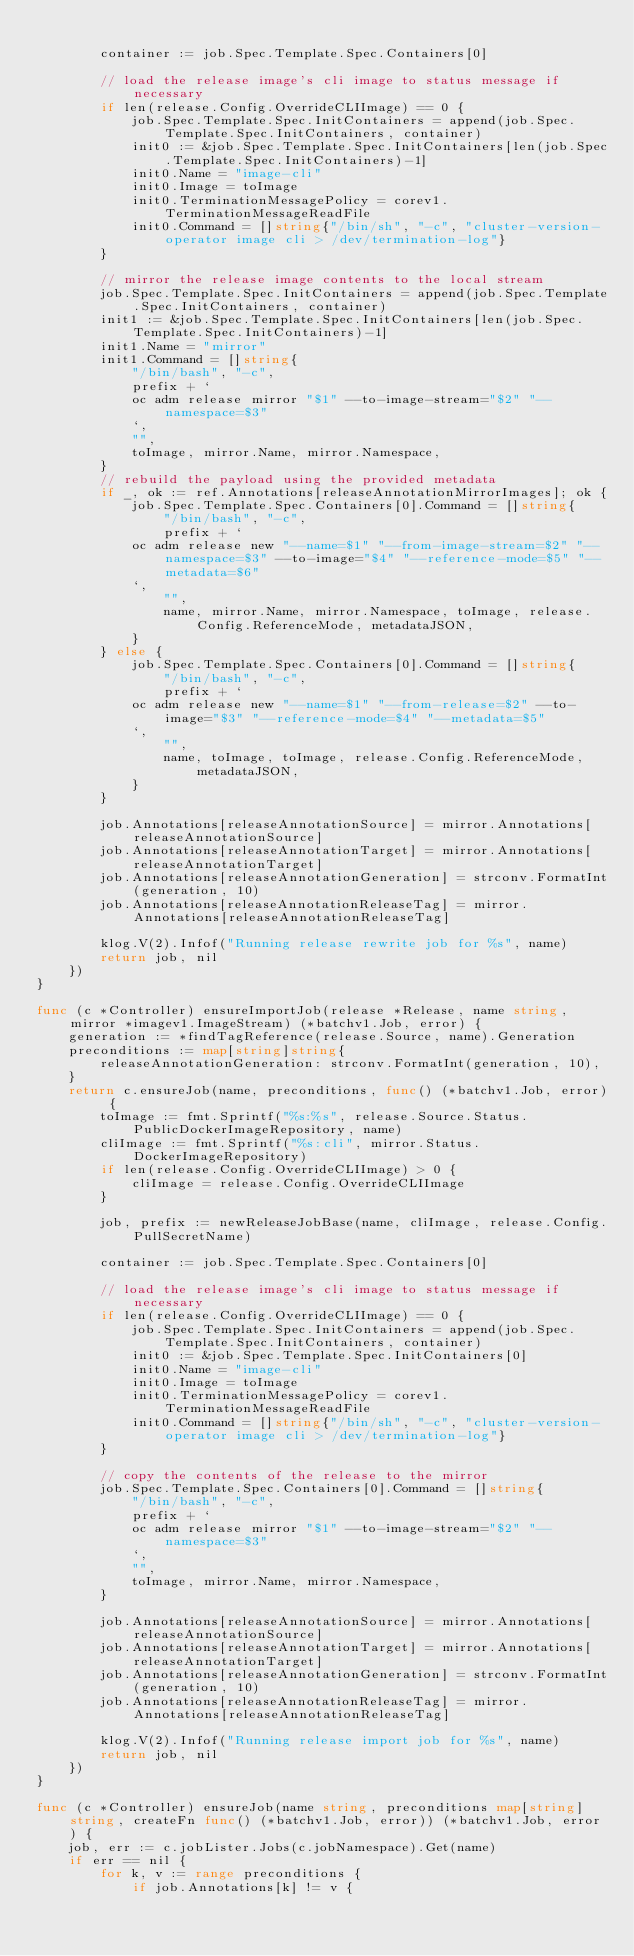<code> <loc_0><loc_0><loc_500><loc_500><_Go_>
		container := job.Spec.Template.Spec.Containers[0]

		// load the release image's cli image to status message if necessary
		if len(release.Config.OverrideCLIImage) == 0 {
			job.Spec.Template.Spec.InitContainers = append(job.Spec.Template.Spec.InitContainers, container)
			init0 := &job.Spec.Template.Spec.InitContainers[len(job.Spec.Template.Spec.InitContainers)-1]
			init0.Name = "image-cli"
			init0.Image = toImage
			init0.TerminationMessagePolicy = corev1.TerminationMessageReadFile
			init0.Command = []string{"/bin/sh", "-c", "cluster-version-operator image cli > /dev/termination-log"}
		}

		// mirror the release image contents to the local stream
		job.Spec.Template.Spec.InitContainers = append(job.Spec.Template.Spec.InitContainers, container)
		init1 := &job.Spec.Template.Spec.InitContainers[len(job.Spec.Template.Spec.InitContainers)-1]
		init1.Name = "mirror"
		init1.Command = []string{
			"/bin/bash", "-c",
			prefix + `
			oc adm release mirror "$1" --to-image-stream="$2" "--namespace=$3"
			`,
			"",
			toImage, mirror.Name, mirror.Namespace,
		}
		// rebuild the payload using the provided metadata
		if _, ok := ref.Annotations[releaseAnnotationMirrorImages]; ok {
			job.Spec.Template.Spec.Containers[0].Command = []string{
				"/bin/bash", "-c",
				prefix + `
			oc adm release new "--name=$1" "--from-image-stream=$2" "--namespace=$3" --to-image="$4" "--reference-mode=$5" "--metadata=$6"
			`,
				"",
				name, mirror.Name, mirror.Namespace, toImage, release.Config.ReferenceMode, metadataJSON,
			}
		} else {
			job.Spec.Template.Spec.Containers[0].Command = []string{
				"/bin/bash", "-c",
				prefix + `
			oc adm release new "--name=$1" "--from-release=$2" --to-image="$3" "--reference-mode=$4" "--metadata=$5"
			`,
				"",
				name, toImage, toImage, release.Config.ReferenceMode, metadataJSON,
			}
		}

		job.Annotations[releaseAnnotationSource] = mirror.Annotations[releaseAnnotationSource]
		job.Annotations[releaseAnnotationTarget] = mirror.Annotations[releaseAnnotationTarget]
		job.Annotations[releaseAnnotationGeneration] = strconv.FormatInt(generation, 10)
		job.Annotations[releaseAnnotationReleaseTag] = mirror.Annotations[releaseAnnotationReleaseTag]

		klog.V(2).Infof("Running release rewrite job for %s", name)
		return job, nil
	})
}

func (c *Controller) ensureImportJob(release *Release, name string, mirror *imagev1.ImageStream) (*batchv1.Job, error) {
	generation := *findTagReference(release.Source, name).Generation
	preconditions := map[string]string{
		releaseAnnotationGeneration: strconv.FormatInt(generation, 10),
	}
	return c.ensureJob(name, preconditions, func() (*batchv1.Job, error) {
		toImage := fmt.Sprintf("%s:%s", release.Source.Status.PublicDockerImageRepository, name)
		cliImage := fmt.Sprintf("%s:cli", mirror.Status.DockerImageRepository)
		if len(release.Config.OverrideCLIImage) > 0 {
			cliImage = release.Config.OverrideCLIImage
		}

		job, prefix := newReleaseJobBase(name, cliImage, release.Config.PullSecretName)

		container := job.Spec.Template.Spec.Containers[0]

		// load the release image's cli image to status message if necessary
		if len(release.Config.OverrideCLIImage) == 0 {
			job.Spec.Template.Spec.InitContainers = append(job.Spec.Template.Spec.InitContainers, container)
			init0 := &job.Spec.Template.Spec.InitContainers[0]
			init0.Name = "image-cli"
			init0.Image = toImage
			init0.TerminationMessagePolicy = corev1.TerminationMessageReadFile
			init0.Command = []string{"/bin/sh", "-c", "cluster-version-operator image cli > /dev/termination-log"}
		}

		// copy the contents of the release to the mirror
		job.Spec.Template.Spec.Containers[0].Command = []string{
			"/bin/bash", "-c",
			prefix + `
			oc adm release mirror "$1" --to-image-stream="$2" "--namespace=$3"
			`,
			"",
			toImage, mirror.Name, mirror.Namespace,
		}

		job.Annotations[releaseAnnotationSource] = mirror.Annotations[releaseAnnotationSource]
		job.Annotations[releaseAnnotationTarget] = mirror.Annotations[releaseAnnotationTarget]
		job.Annotations[releaseAnnotationGeneration] = strconv.FormatInt(generation, 10)
		job.Annotations[releaseAnnotationReleaseTag] = mirror.Annotations[releaseAnnotationReleaseTag]

		klog.V(2).Infof("Running release import job for %s", name)
		return job, nil
	})
}

func (c *Controller) ensureJob(name string, preconditions map[string]string, createFn func() (*batchv1.Job, error)) (*batchv1.Job, error) {
	job, err := c.jobLister.Jobs(c.jobNamespace).Get(name)
	if err == nil {
		for k, v := range preconditions {
			if job.Annotations[k] != v {</code> 